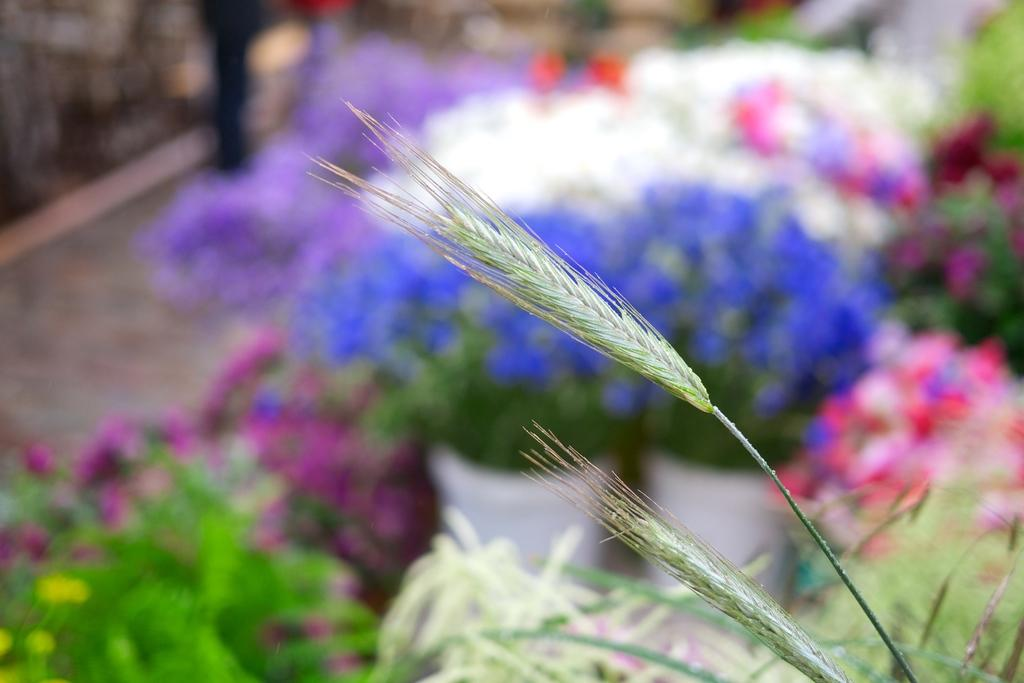What type of living organisms can be seen in the image? Plants and flowers can be seen in the image. Can you describe the background of the image? The background of the image is blurred. What type of verse is being recited by the suit in the image? There is no suit or verse present in the image; it features plants and flowers with a blurred background. What kind of trouble is the flower experiencing in the image? There is no indication of any trouble experienced by the flowers in the image. 